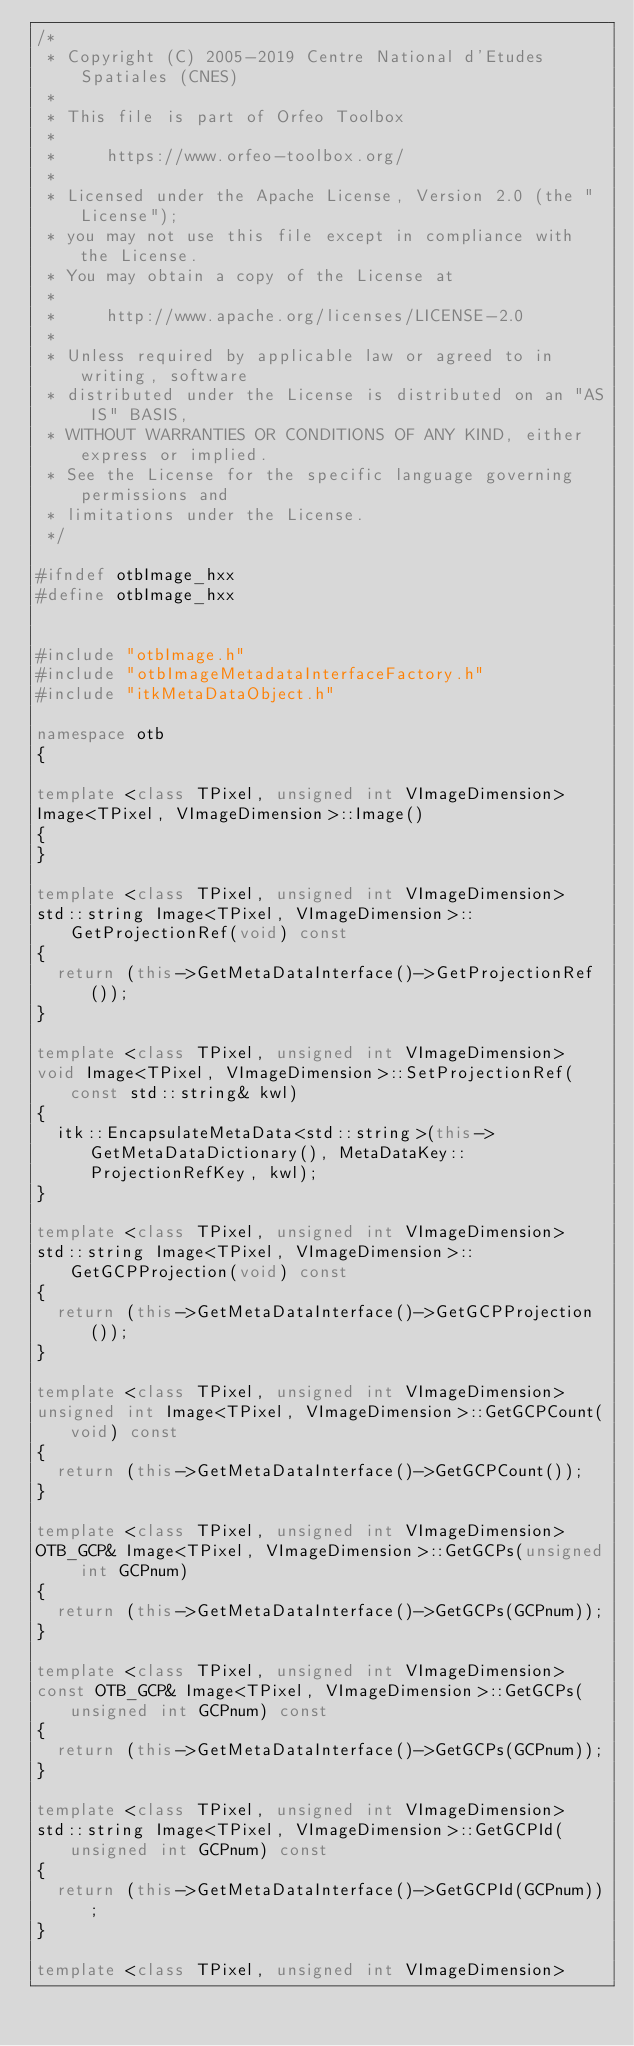<code> <loc_0><loc_0><loc_500><loc_500><_C++_>/*
 * Copyright (C) 2005-2019 Centre National d'Etudes Spatiales (CNES)
 *
 * This file is part of Orfeo Toolbox
 *
 *     https://www.orfeo-toolbox.org/
 *
 * Licensed under the Apache License, Version 2.0 (the "License");
 * you may not use this file except in compliance with the License.
 * You may obtain a copy of the License at
 *
 *     http://www.apache.org/licenses/LICENSE-2.0
 *
 * Unless required by applicable law or agreed to in writing, software
 * distributed under the License is distributed on an "AS IS" BASIS,
 * WITHOUT WARRANTIES OR CONDITIONS OF ANY KIND, either express or implied.
 * See the License for the specific language governing permissions and
 * limitations under the License.
 */

#ifndef otbImage_hxx
#define otbImage_hxx


#include "otbImage.h"
#include "otbImageMetadataInterfaceFactory.h"
#include "itkMetaDataObject.h"

namespace otb
{

template <class TPixel, unsigned int VImageDimension>
Image<TPixel, VImageDimension>::Image()
{
}

template <class TPixel, unsigned int VImageDimension>
std::string Image<TPixel, VImageDimension>::GetProjectionRef(void) const
{
  return (this->GetMetaDataInterface()->GetProjectionRef());
}

template <class TPixel, unsigned int VImageDimension>
void Image<TPixel, VImageDimension>::SetProjectionRef(const std::string& kwl)
{
  itk::EncapsulateMetaData<std::string>(this->GetMetaDataDictionary(), MetaDataKey::ProjectionRefKey, kwl);
}

template <class TPixel, unsigned int VImageDimension>
std::string Image<TPixel, VImageDimension>::GetGCPProjection(void) const
{
  return (this->GetMetaDataInterface()->GetGCPProjection());
}

template <class TPixel, unsigned int VImageDimension>
unsigned int Image<TPixel, VImageDimension>::GetGCPCount(void) const
{
  return (this->GetMetaDataInterface()->GetGCPCount());
}

template <class TPixel, unsigned int VImageDimension>
OTB_GCP& Image<TPixel, VImageDimension>::GetGCPs(unsigned int GCPnum)
{
  return (this->GetMetaDataInterface()->GetGCPs(GCPnum));
}

template <class TPixel, unsigned int VImageDimension>
const OTB_GCP& Image<TPixel, VImageDimension>::GetGCPs(unsigned int GCPnum) const
{
  return (this->GetMetaDataInterface()->GetGCPs(GCPnum));
}

template <class TPixel, unsigned int VImageDimension>
std::string Image<TPixel, VImageDimension>::GetGCPId(unsigned int GCPnum) const
{
  return (this->GetMetaDataInterface()->GetGCPId(GCPnum));
}

template <class TPixel, unsigned int VImageDimension></code> 